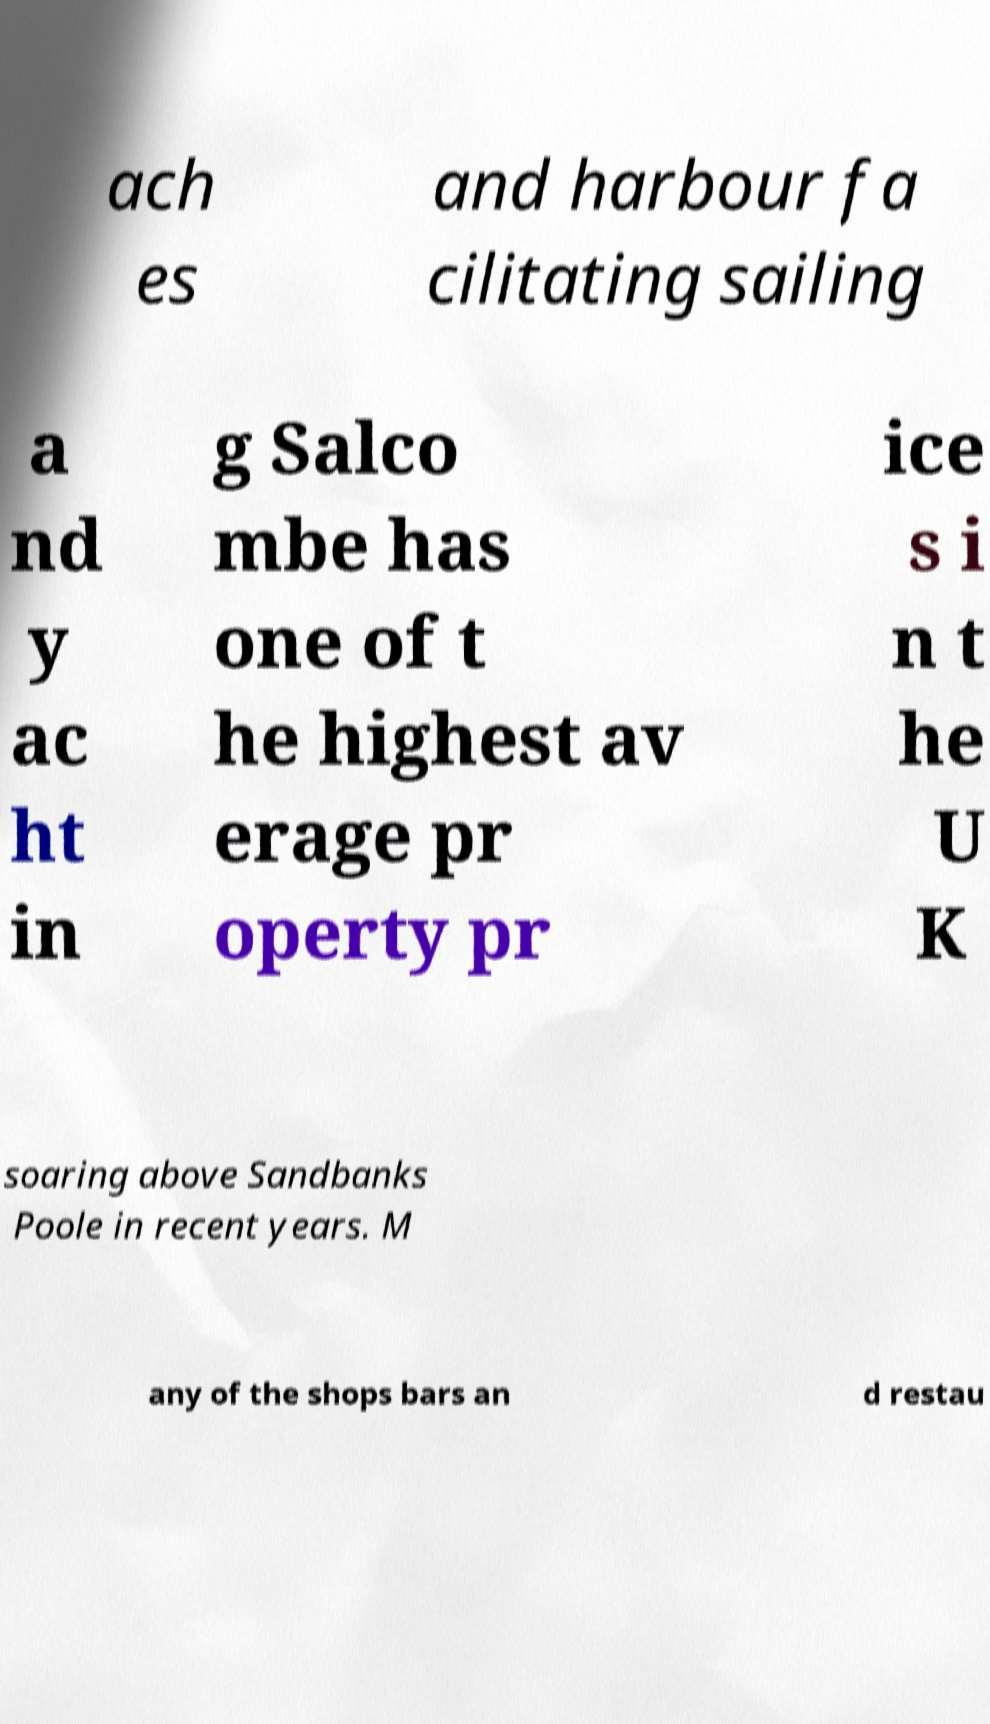Could you assist in decoding the text presented in this image and type it out clearly? ach es and harbour fa cilitating sailing a nd y ac ht in g Salco mbe has one of t he highest av erage pr operty pr ice s i n t he U K soaring above Sandbanks Poole in recent years. M any of the shops bars an d restau 